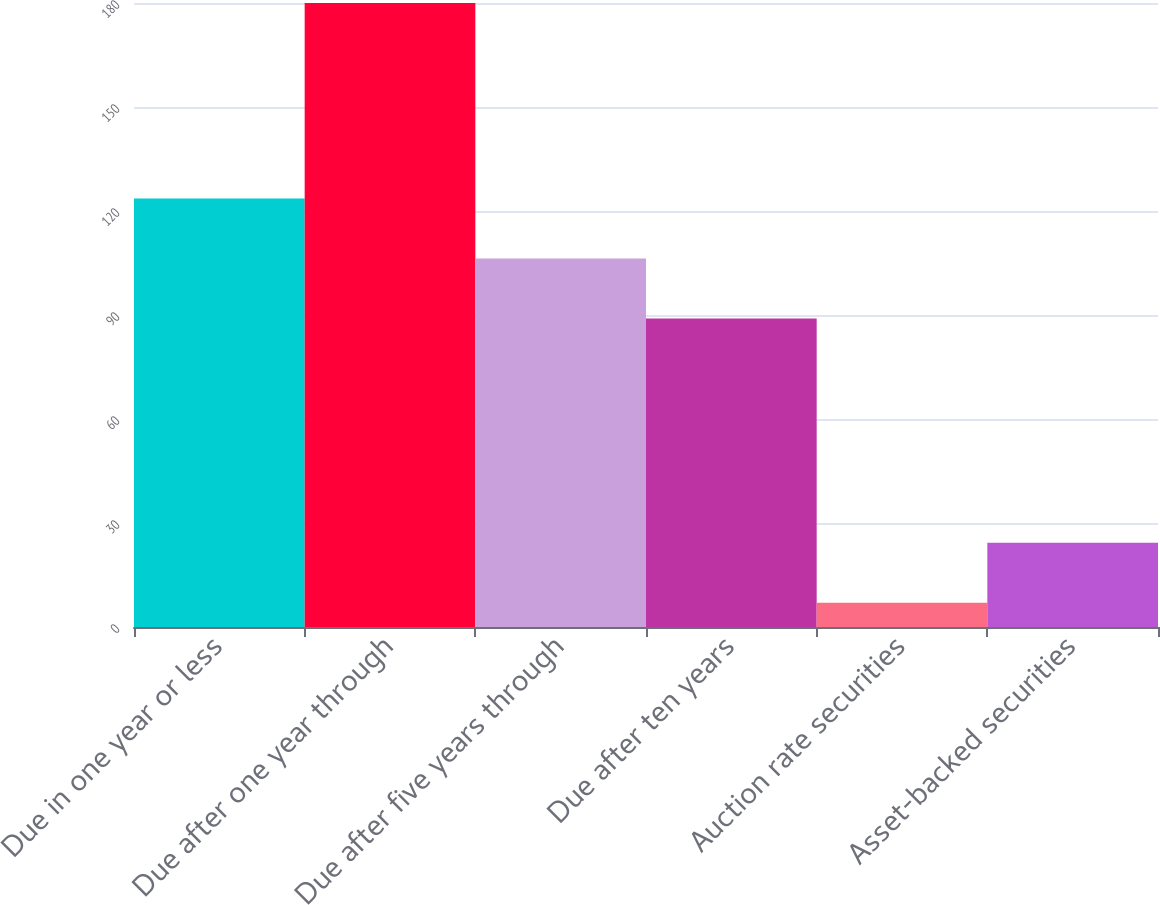Convert chart. <chart><loc_0><loc_0><loc_500><loc_500><bar_chart><fcel>Due in one year or less<fcel>Due after one year through<fcel>Due after five years through<fcel>Due after ten years<fcel>Auction rate securities<fcel>Asset-backed securities<nl><fcel>123.6<fcel>180<fcel>106.3<fcel>89<fcel>7<fcel>24.3<nl></chart> 